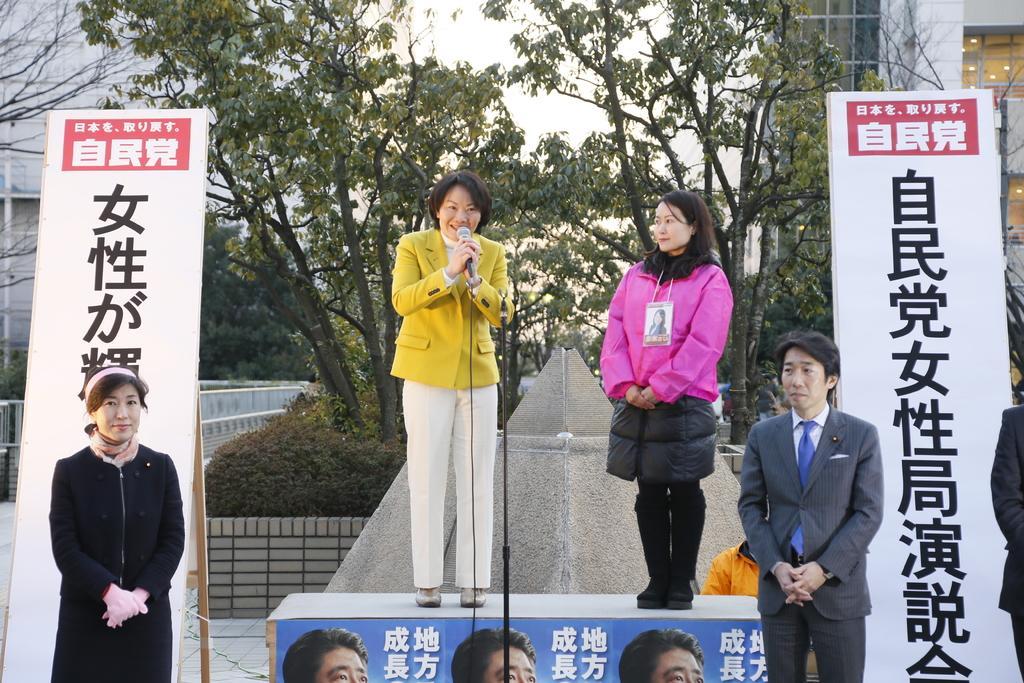Please provide a concise description of this image. In this picture I can see 3 women, a man and a person in front and I see that the woman on the platform is holding a mic. In the middle of this picture I can number of trees, plants and I can also see few boards on which there is something written. In the background I can see few buildings and the sky. 